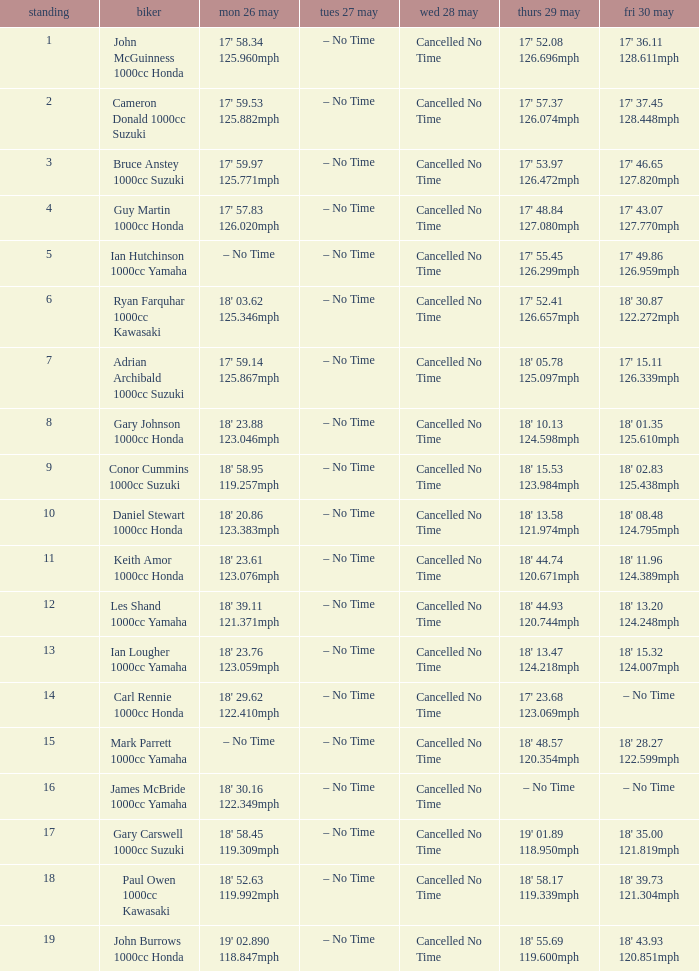What tims is wed may 28 and mon may 26 is 17' 58.34 125.960mph? Cancelled No Time. 